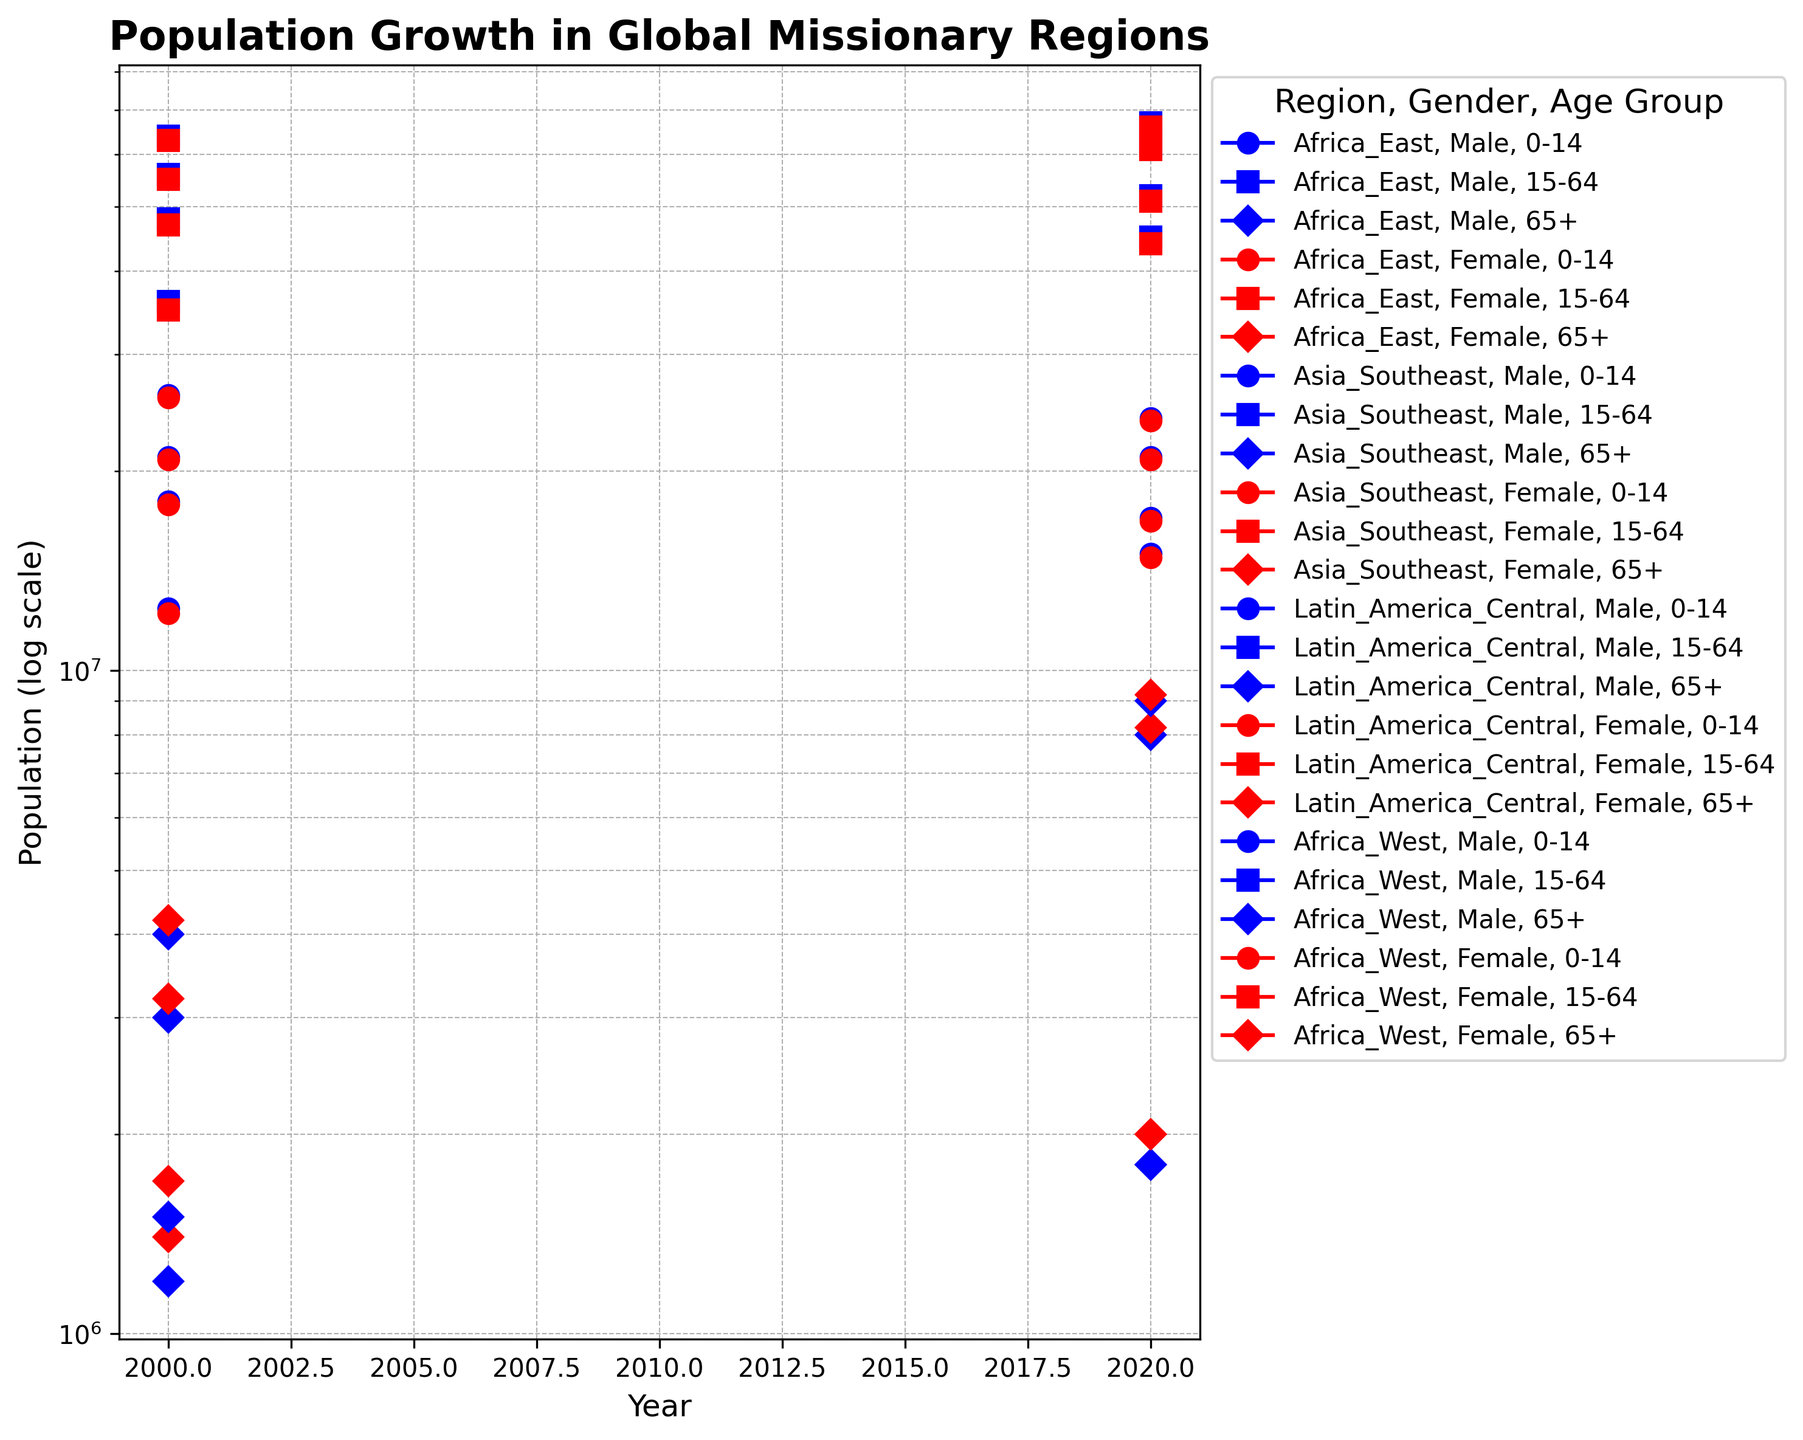What general trend can be observed in the population of the 0-14 age group across all regions from 2000 to 2020? We look at the logscaled population points for the 0-14 age group across all regions for the years 2000 and 2020. In Africa East and Africa West, there is an increase, while in Asia Southeast and Latin America Central, there is a decrease. This indicates a mixed trend where some regions are experiencing growth and others a decline.
Answer: Mixed trend Which region shows the largest increase in the 65+ age group population from 2000 to 2020? First, we identify the 65+ age group populations for each region in 2000 and 2020. Comparing the data points, Africa East has an increase from 1.2M (male) and 1.4M (female) to 1.8M (male) and 2M (female). However, Asia Southeast shows an increase from 3M (male) and 3.2M (female) to 8M (male) and 8.2M (female), making Asia Southeast the region with the largest increase.
Answer: Asia Southeast How does the population growth in the 15-64 age group in Africa East compare to Latin America Central from 2000 to 2020? We look at the 15-64 age group data for both regions. In Africa East, the population grows from 36M (male) and 35M (female) to 45M (male) and 44M (female). In Latin America Central, it grows from 64M (male) and 63M (female) to 67M (male) and 66M (female). Africa East's growth is from 71M to 89M, a difference of 18M, whereas Latin America Central's growth is from 127M to 133M, a difference of 6M.
Answer: Africa East has more growth Which gender, on average, has a higher population in the 15-64 age group in Asia Southeast in 2020? We compare the populations for males and females in the 15-64 age group in Asia Southeast for 2020. Males have a population of 62M, and females have 61M. The average is higher for males.
Answer: Males Among the regions listed, which has the smallest female 0-14 age group population in 2000, and what is the value? We isolate the female 0-14 age group populations for 2000. The values are 12.2M (Africa East), 20.8M (Asia Southeast), 25.8M (Latin America Central), and 17.8M (Africa West). The smallest value is in Africa East.
Answer: Africa_East, 12.2M What is the growth rate of the 0-14 age group population in Africa East from 2000 to 2020? For the 0-14 age group in Africa East, the population grows from 12.4M (male) and 12.2M (female) to 15M (male) and 14.8M (female). The total growth for this group is from 24.6M to 29.8M. The growth rate is (29.8-24.6)/24.6 ≈ 21.14%.
Answer: 21.14% In which year does Africa West have the larger 0-14 female population, 2000 or 2020? We compare the female 0-14 populations for Africa West in 2000 and 2020. It is 17.8M in 2000 and increases to 20.8M in 2020, meaning the larger population is in 2020.
Answer: 2020 What is the total population of males in the 15-64 age group across all regions in 2020? Adding the 15-64 age group male populations across all regions for 2020: Africa East (45M), Africa West (52M), Asia Southeast (62M), and Latin America Central (67M). Summing these, 45 + 52 + 62 + 67 = 226M.
Answer: 226M 